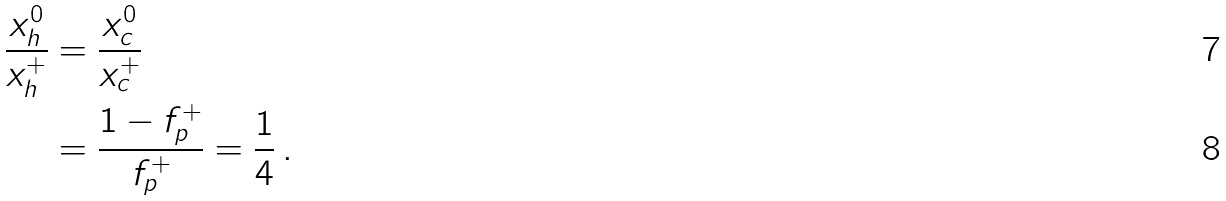<formula> <loc_0><loc_0><loc_500><loc_500>\frac { x ^ { 0 } _ { h } } { x ^ { + } _ { h } } & = \frac { x ^ { 0 } _ { c } } { x ^ { + } _ { c } } \\ & = \frac { 1 - f _ { p } ^ { + } } { f _ { p } ^ { + } } = \frac { 1 } { 4 } \, .</formula> 